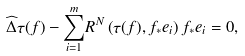<formula> <loc_0><loc_0><loc_500><loc_500>\widehat { \Delta } \tau ( f ) - \underset { i = 1 } { \overset { m } { \sum } } R ^ { N } \left ( \tau ( f ) , f _ { * } e _ { i } \right ) f _ { * } e _ { i } = 0 ,</formula> 